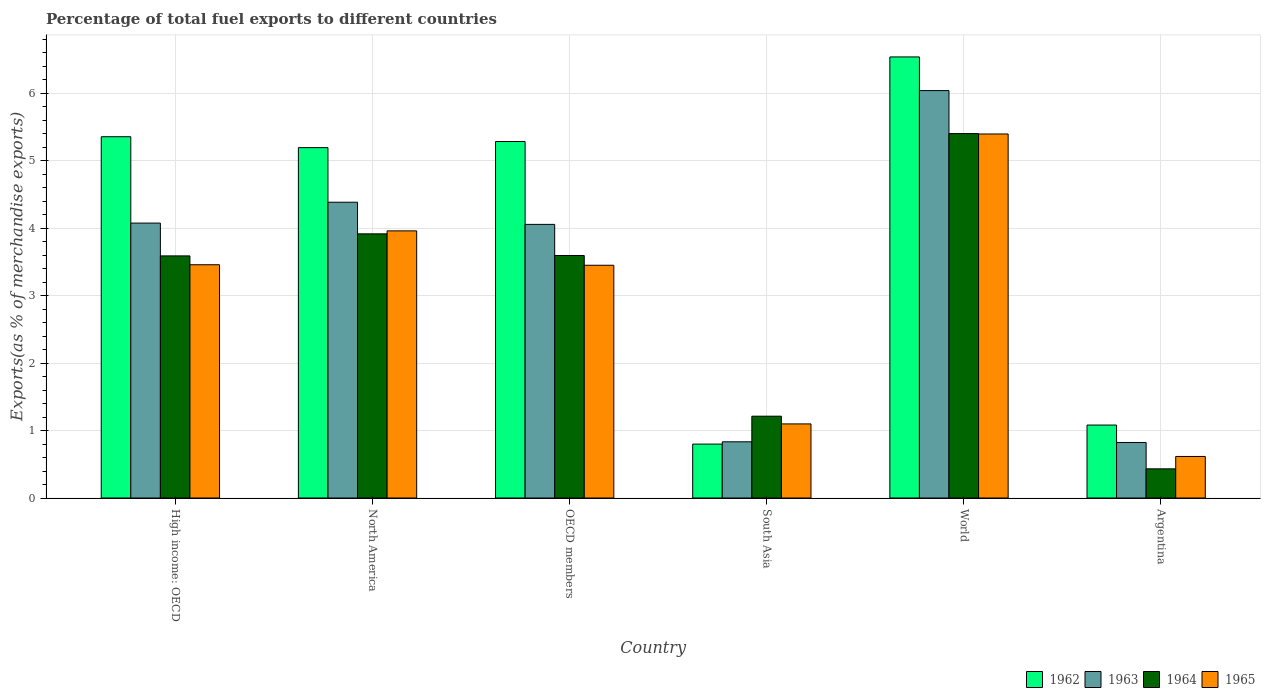How many different coloured bars are there?
Your response must be concise. 4. How many groups of bars are there?
Your answer should be very brief. 6. Are the number of bars per tick equal to the number of legend labels?
Give a very brief answer. Yes. How many bars are there on the 4th tick from the right?
Keep it short and to the point. 4. In how many cases, is the number of bars for a given country not equal to the number of legend labels?
Your response must be concise. 0. What is the percentage of exports to different countries in 1962 in High income: OECD?
Keep it short and to the point. 5.35. Across all countries, what is the maximum percentage of exports to different countries in 1965?
Your response must be concise. 5.39. Across all countries, what is the minimum percentage of exports to different countries in 1964?
Your answer should be very brief. 0.43. What is the total percentage of exports to different countries in 1962 in the graph?
Offer a terse response. 24.24. What is the difference between the percentage of exports to different countries in 1965 in North America and that in OECD members?
Ensure brevity in your answer.  0.51. What is the difference between the percentage of exports to different countries in 1963 in North America and the percentage of exports to different countries in 1964 in Argentina?
Keep it short and to the point. 3.95. What is the average percentage of exports to different countries in 1965 per country?
Provide a succinct answer. 2.99. What is the difference between the percentage of exports to different countries of/in 1965 and percentage of exports to different countries of/in 1964 in High income: OECD?
Provide a short and direct response. -0.13. In how many countries, is the percentage of exports to different countries in 1962 greater than 0.8 %?
Offer a very short reply. 5. What is the ratio of the percentage of exports to different countries in 1964 in North America to that in South Asia?
Give a very brief answer. 3.23. Is the difference between the percentage of exports to different countries in 1965 in OECD members and World greater than the difference between the percentage of exports to different countries in 1964 in OECD members and World?
Offer a terse response. No. What is the difference between the highest and the second highest percentage of exports to different countries in 1962?
Offer a terse response. -0.07. What is the difference between the highest and the lowest percentage of exports to different countries in 1963?
Provide a succinct answer. 5.21. Is the sum of the percentage of exports to different countries in 1963 in North America and OECD members greater than the maximum percentage of exports to different countries in 1964 across all countries?
Your response must be concise. Yes. Is it the case that in every country, the sum of the percentage of exports to different countries in 1963 and percentage of exports to different countries in 1962 is greater than the sum of percentage of exports to different countries in 1964 and percentage of exports to different countries in 1965?
Keep it short and to the point. No. What does the 3rd bar from the left in North America represents?
Provide a succinct answer. 1964. What does the 1st bar from the right in Argentina represents?
Make the answer very short. 1965. How many bars are there?
Your answer should be compact. 24. Are all the bars in the graph horizontal?
Offer a very short reply. No. What is the difference between two consecutive major ticks on the Y-axis?
Ensure brevity in your answer.  1. Does the graph contain any zero values?
Your response must be concise. No. Does the graph contain grids?
Your answer should be very brief. Yes. Where does the legend appear in the graph?
Your answer should be compact. Bottom right. How many legend labels are there?
Make the answer very short. 4. How are the legend labels stacked?
Ensure brevity in your answer.  Horizontal. What is the title of the graph?
Provide a succinct answer. Percentage of total fuel exports to different countries. Does "2011" appear as one of the legend labels in the graph?
Provide a short and direct response. No. What is the label or title of the X-axis?
Provide a succinct answer. Country. What is the label or title of the Y-axis?
Provide a succinct answer. Exports(as % of merchandise exports). What is the Exports(as % of merchandise exports) of 1962 in High income: OECD?
Your answer should be very brief. 5.35. What is the Exports(as % of merchandise exports) in 1963 in High income: OECD?
Offer a very short reply. 4.07. What is the Exports(as % of merchandise exports) of 1964 in High income: OECD?
Your answer should be compact. 3.59. What is the Exports(as % of merchandise exports) in 1965 in High income: OECD?
Provide a short and direct response. 3.46. What is the Exports(as % of merchandise exports) of 1962 in North America?
Make the answer very short. 5.19. What is the Exports(as % of merchandise exports) of 1963 in North America?
Offer a very short reply. 4.38. What is the Exports(as % of merchandise exports) of 1964 in North America?
Provide a succinct answer. 3.91. What is the Exports(as % of merchandise exports) of 1965 in North America?
Your response must be concise. 3.96. What is the Exports(as % of merchandise exports) in 1962 in OECD members?
Offer a terse response. 5.28. What is the Exports(as % of merchandise exports) in 1963 in OECD members?
Your answer should be compact. 4.05. What is the Exports(as % of merchandise exports) of 1964 in OECD members?
Offer a very short reply. 3.59. What is the Exports(as % of merchandise exports) in 1965 in OECD members?
Provide a succinct answer. 3.45. What is the Exports(as % of merchandise exports) of 1962 in South Asia?
Provide a succinct answer. 0.8. What is the Exports(as % of merchandise exports) in 1963 in South Asia?
Your answer should be compact. 0.83. What is the Exports(as % of merchandise exports) of 1964 in South Asia?
Provide a succinct answer. 1.21. What is the Exports(as % of merchandise exports) in 1965 in South Asia?
Make the answer very short. 1.1. What is the Exports(as % of merchandise exports) of 1962 in World?
Ensure brevity in your answer.  6.53. What is the Exports(as % of merchandise exports) of 1963 in World?
Provide a short and direct response. 6.04. What is the Exports(as % of merchandise exports) of 1964 in World?
Your answer should be very brief. 5.4. What is the Exports(as % of merchandise exports) of 1965 in World?
Provide a succinct answer. 5.39. What is the Exports(as % of merchandise exports) of 1962 in Argentina?
Your response must be concise. 1.08. What is the Exports(as % of merchandise exports) of 1963 in Argentina?
Your answer should be compact. 0.82. What is the Exports(as % of merchandise exports) of 1964 in Argentina?
Give a very brief answer. 0.43. What is the Exports(as % of merchandise exports) in 1965 in Argentina?
Offer a very short reply. 0.62. Across all countries, what is the maximum Exports(as % of merchandise exports) of 1962?
Ensure brevity in your answer.  6.53. Across all countries, what is the maximum Exports(as % of merchandise exports) in 1963?
Provide a succinct answer. 6.04. Across all countries, what is the maximum Exports(as % of merchandise exports) of 1964?
Ensure brevity in your answer.  5.4. Across all countries, what is the maximum Exports(as % of merchandise exports) in 1965?
Make the answer very short. 5.39. Across all countries, what is the minimum Exports(as % of merchandise exports) in 1962?
Your answer should be very brief. 0.8. Across all countries, what is the minimum Exports(as % of merchandise exports) of 1963?
Make the answer very short. 0.82. Across all countries, what is the minimum Exports(as % of merchandise exports) in 1964?
Your answer should be compact. 0.43. Across all countries, what is the minimum Exports(as % of merchandise exports) in 1965?
Your response must be concise. 0.62. What is the total Exports(as % of merchandise exports) of 1962 in the graph?
Give a very brief answer. 24.24. What is the total Exports(as % of merchandise exports) in 1963 in the graph?
Your answer should be very brief. 20.2. What is the total Exports(as % of merchandise exports) of 1964 in the graph?
Offer a very short reply. 18.14. What is the total Exports(as % of merchandise exports) in 1965 in the graph?
Ensure brevity in your answer.  17.97. What is the difference between the Exports(as % of merchandise exports) in 1962 in High income: OECD and that in North America?
Keep it short and to the point. 0.16. What is the difference between the Exports(as % of merchandise exports) of 1963 in High income: OECD and that in North America?
Give a very brief answer. -0.31. What is the difference between the Exports(as % of merchandise exports) of 1964 in High income: OECD and that in North America?
Offer a terse response. -0.33. What is the difference between the Exports(as % of merchandise exports) in 1965 in High income: OECD and that in North America?
Ensure brevity in your answer.  -0.5. What is the difference between the Exports(as % of merchandise exports) in 1962 in High income: OECD and that in OECD members?
Make the answer very short. 0.07. What is the difference between the Exports(as % of merchandise exports) in 1963 in High income: OECD and that in OECD members?
Ensure brevity in your answer.  0.02. What is the difference between the Exports(as % of merchandise exports) in 1964 in High income: OECD and that in OECD members?
Keep it short and to the point. -0.01. What is the difference between the Exports(as % of merchandise exports) in 1965 in High income: OECD and that in OECD members?
Provide a short and direct response. 0.01. What is the difference between the Exports(as % of merchandise exports) in 1962 in High income: OECD and that in South Asia?
Offer a terse response. 4.55. What is the difference between the Exports(as % of merchandise exports) of 1963 in High income: OECD and that in South Asia?
Keep it short and to the point. 3.24. What is the difference between the Exports(as % of merchandise exports) of 1964 in High income: OECD and that in South Asia?
Provide a succinct answer. 2.37. What is the difference between the Exports(as % of merchandise exports) of 1965 in High income: OECD and that in South Asia?
Your answer should be very brief. 2.36. What is the difference between the Exports(as % of merchandise exports) in 1962 in High income: OECD and that in World?
Give a very brief answer. -1.18. What is the difference between the Exports(as % of merchandise exports) of 1963 in High income: OECD and that in World?
Provide a succinct answer. -1.96. What is the difference between the Exports(as % of merchandise exports) of 1964 in High income: OECD and that in World?
Provide a short and direct response. -1.81. What is the difference between the Exports(as % of merchandise exports) in 1965 in High income: OECD and that in World?
Provide a succinct answer. -1.94. What is the difference between the Exports(as % of merchandise exports) of 1962 in High income: OECD and that in Argentina?
Your response must be concise. 4.27. What is the difference between the Exports(as % of merchandise exports) in 1963 in High income: OECD and that in Argentina?
Keep it short and to the point. 3.25. What is the difference between the Exports(as % of merchandise exports) in 1964 in High income: OECD and that in Argentina?
Provide a short and direct response. 3.15. What is the difference between the Exports(as % of merchandise exports) in 1965 in High income: OECD and that in Argentina?
Keep it short and to the point. 2.84. What is the difference between the Exports(as % of merchandise exports) of 1962 in North America and that in OECD members?
Your response must be concise. -0.09. What is the difference between the Exports(as % of merchandise exports) in 1963 in North America and that in OECD members?
Keep it short and to the point. 0.33. What is the difference between the Exports(as % of merchandise exports) of 1964 in North America and that in OECD members?
Offer a very short reply. 0.32. What is the difference between the Exports(as % of merchandise exports) of 1965 in North America and that in OECD members?
Keep it short and to the point. 0.51. What is the difference between the Exports(as % of merchandise exports) of 1962 in North America and that in South Asia?
Ensure brevity in your answer.  4.39. What is the difference between the Exports(as % of merchandise exports) in 1963 in North America and that in South Asia?
Make the answer very short. 3.55. What is the difference between the Exports(as % of merchandise exports) in 1964 in North America and that in South Asia?
Your answer should be compact. 2.7. What is the difference between the Exports(as % of merchandise exports) of 1965 in North America and that in South Asia?
Ensure brevity in your answer.  2.86. What is the difference between the Exports(as % of merchandise exports) in 1962 in North America and that in World?
Your answer should be very brief. -1.34. What is the difference between the Exports(as % of merchandise exports) of 1963 in North America and that in World?
Your answer should be very brief. -1.65. What is the difference between the Exports(as % of merchandise exports) of 1964 in North America and that in World?
Offer a terse response. -1.49. What is the difference between the Exports(as % of merchandise exports) of 1965 in North America and that in World?
Your answer should be compact. -1.44. What is the difference between the Exports(as % of merchandise exports) of 1962 in North America and that in Argentina?
Your answer should be compact. 4.11. What is the difference between the Exports(as % of merchandise exports) in 1963 in North America and that in Argentina?
Your response must be concise. 3.56. What is the difference between the Exports(as % of merchandise exports) of 1964 in North America and that in Argentina?
Provide a succinct answer. 3.48. What is the difference between the Exports(as % of merchandise exports) in 1965 in North America and that in Argentina?
Provide a short and direct response. 3.34. What is the difference between the Exports(as % of merchandise exports) of 1962 in OECD members and that in South Asia?
Provide a short and direct response. 4.48. What is the difference between the Exports(as % of merchandise exports) of 1963 in OECD members and that in South Asia?
Ensure brevity in your answer.  3.22. What is the difference between the Exports(as % of merchandise exports) of 1964 in OECD members and that in South Asia?
Provide a succinct answer. 2.38. What is the difference between the Exports(as % of merchandise exports) in 1965 in OECD members and that in South Asia?
Give a very brief answer. 2.35. What is the difference between the Exports(as % of merchandise exports) in 1962 in OECD members and that in World?
Offer a very short reply. -1.25. What is the difference between the Exports(as % of merchandise exports) in 1963 in OECD members and that in World?
Your answer should be very brief. -1.98. What is the difference between the Exports(as % of merchandise exports) in 1964 in OECD members and that in World?
Give a very brief answer. -1.81. What is the difference between the Exports(as % of merchandise exports) of 1965 in OECD members and that in World?
Provide a short and direct response. -1.94. What is the difference between the Exports(as % of merchandise exports) in 1962 in OECD members and that in Argentina?
Provide a succinct answer. 4.2. What is the difference between the Exports(as % of merchandise exports) of 1963 in OECD members and that in Argentina?
Keep it short and to the point. 3.23. What is the difference between the Exports(as % of merchandise exports) of 1964 in OECD members and that in Argentina?
Keep it short and to the point. 3.16. What is the difference between the Exports(as % of merchandise exports) in 1965 in OECD members and that in Argentina?
Ensure brevity in your answer.  2.83. What is the difference between the Exports(as % of merchandise exports) of 1962 in South Asia and that in World?
Your answer should be very brief. -5.74. What is the difference between the Exports(as % of merchandise exports) of 1963 in South Asia and that in World?
Ensure brevity in your answer.  -5.2. What is the difference between the Exports(as % of merchandise exports) in 1964 in South Asia and that in World?
Give a very brief answer. -4.19. What is the difference between the Exports(as % of merchandise exports) of 1965 in South Asia and that in World?
Keep it short and to the point. -4.3. What is the difference between the Exports(as % of merchandise exports) of 1962 in South Asia and that in Argentina?
Your answer should be very brief. -0.28. What is the difference between the Exports(as % of merchandise exports) in 1963 in South Asia and that in Argentina?
Make the answer very short. 0.01. What is the difference between the Exports(as % of merchandise exports) of 1964 in South Asia and that in Argentina?
Provide a short and direct response. 0.78. What is the difference between the Exports(as % of merchandise exports) of 1965 in South Asia and that in Argentina?
Ensure brevity in your answer.  0.48. What is the difference between the Exports(as % of merchandise exports) of 1962 in World and that in Argentina?
Make the answer very short. 5.45. What is the difference between the Exports(as % of merchandise exports) in 1963 in World and that in Argentina?
Offer a terse response. 5.21. What is the difference between the Exports(as % of merchandise exports) in 1964 in World and that in Argentina?
Ensure brevity in your answer.  4.97. What is the difference between the Exports(as % of merchandise exports) in 1965 in World and that in Argentina?
Your answer should be very brief. 4.78. What is the difference between the Exports(as % of merchandise exports) of 1962 in High income: OECD and the Exports(as % of merchandise exports) of 1963 in North America?
Your answer should be compact. 0.97. What is the difference between the Exports(as % of merchandise exports) of 1962 in High income: OECD and the Exports(as % of merchandise exports) of 1964 in North America?
Your answer should be very brief. 1.44. What is the difference between the Exports(as % of merchandise exports) of 1962 in High income: OECD and the Exports(as % of merchandise exports) of 1965 in North America?
Provide a succinct answer. 1.39. What is the difference between the Exports(as % of merchandise exports) of 1963 in High income: OECD and the Exports(as % of merchandise exports) of 1964 in North America?
Make the answer very short. 0.16. What is the difference between the Exports(as % of merchandise exports) in 1963 in High income: OECD and the Exports(as % of merchandise exports) in 1965 in North America?
Give a very brief answer. 0.12. What is the difference between the Exports(as % of merchandise exports) of 1964 in High income: OECD and the Exports(as % of merchandise exports) of 1965 in North America?
Your answer should be very brief. -0.37. What is the difference between the Exports(as % of merchandise exports) of 1962 in High income: OECD and the Exports(as % of merchandise exports) of 1963 in OECD members?
Your answer should be very brief. 1.3. What is the difference between the Exports(as % of merchandise exports) of 1962 in High income: OECD and the Exports(as % of merchandise exports) of 1964 in OECD members?
Make the answer very short. 1.76. What is the difference between the Exports(as % of merchandise exports) of 1962 in High income: OECD and the Exports(as % of merchandise exports) of 1965 in OECD members?
Keep it short and to the point. 1.9. What is the difference between the Exports(as % of merchandise exports) of 1963 in High income: OECD and the Exports(as % of merchandise exports) of 1964 in OECD members?
Provide a short and direct response. 0.48. What is the difference between the Exports(as % of merchandise exports) in 1963 in High income: OECD and the Exports(as % of merchandise exports) in 1965 in OECD members?
Ensure brevity in your answer.  0.62. What is the difference between the Exports(as % of merchandise exports) of 1964 in High income: OECD and the Exports(as % of merchandise exports) of 1965 in OECD members?
Offer a very short reply. 0.14. What is the difference between the Exports(as % of merchandise exports) in 1962 in High income: OECD and the Exports(as % of merchandise exports) in 1963 in South Asia?
Offer a very short reply. 4.52. What is the difference between the Exports(as % of merchandise exports) in 1962 in High income: OECD and the Exports(as % of merchandise exports) in 1964 in South Asia?
Offer a very short reply. 4.14. What is the difference between the Exports(as % of merchandise exports) in 1962 in High income: OECD and the Exports(as % of merchandise exports) in 1965 in South Asia?
Your response must be concise. 4.25. What is the difference between the Exports(as % of merchandise exports) in 1963 in High income: OECD and the Exports(as % of merchandise exports) in 1964 in South Asia?
Provide a short and direct response. 2.86. What is the difference between the Exports(as % of merchandise exports) in 1963 in High income: OECD and the Exports(as % of merchandise exports) in 1965 in South Asia?
Provide a short and direct response. 2.98. What is the difference between the Exports(as % of merchandise exports) of 1964 in High income: OECD and the Exports(as % of merchandise exports) of 1965 in South Asia?
Give a very brief answer. 2.49. What is the difference between the Exports(as % of merchandise exports) in 1962 in High income: OECD and the Exports(as % of merchandise exports) in 1963 in World?
Give a very brief answer. -0.68. What is the difference between the Exports(as % of merchandise exports) of 1962 in High income: OECD and the Exports(as % of merchandise exports) of 1964 in World?
Your answer should be very brief. -0.05. What is the difference between the Exports(as % of merchandise exports) of 1962 in High income: OECD and the Exports(as % of merchandise exports) of 1965 in World?
Your answer should be very brief. -0.04. What is the difference between the Exports(as % of merchandise exports) of 1963 in High income: OECD and the Exports(as % of merchandise exports) of 1964 in World?
Make the answer very short. -1.33. What is the difference between the Exports(as % of merchandise exports) of 1963 in High income: OECD and the Exports(as % of merchandise exports) of 1965 in World?
Your response must be concise. -1.32. What is the difference between the Exports(as % of merchandise exports) of 1964 in High income: OECD and the Exports(as % of merchandise exports) of 1965 in World?
Your answer should be very brief. -1.81. What is the difference between the Exports(as % of merchandise exports) in 1962 in High income: OECD and the Exports(as % of merchandise exports) in 1963 in Argentina?
Keep it short and to the point. 4.53. What is the difference between the Exports(as % of merchandise exports) of 1962 in High income: OECD and the Exports(as % of merchandise exports) of 1964 in Argentina?
Your response must be concise. 4.92. What is the difference between the Exports(as % of merchandise exports) of 1962 in High income: OECD and the Exports(as % of merchandise exports) of 1965 in Argentina?
Your answer should be very brief. 4.74. What is the difference between the Exports(as % of merchandise exports) of 1963 in High income: OECD and the Exports(as % of merchandise exports) of 1964 in Argentina?
Provide a short and direct response. 3.64. What is the difference between the Exports(as % of merchandise exports) in 1963 in High income: OECD and the Exports(as % of merchandise exports) in 1965 in Argentina?
Your response must be concise. 3.46. What is the difference between the Exports(as % of merchandise exports) in 1964 in High income: OECD and the Exports(as % of merchandise exports) in 1965 in Argentina?
Keep it short and to the point. 2.97. What is the difference between the Exports(as % of merchandise exports) in 1962 in North America and the Exports(as % of merchandise exports) in 1963 in OECD members?
Your answer should be very brief. 1.14. What is the difference between the Exports(as % of merchandise exports) of 1962 in North America and the Exports(as % of merchandise exports) of 1964 in OECD members?
Ensure brevity in your answer.  1.6. What is the difference between the Exports(as % of merchandise exports) in 1962 in North America and the Exports(as % of merchandise exports) in 1965 in OECD members?
Keep it short and to the point. 1.74. What is the difference between the Exports(as % of merchandise exports) of 1963 in North America and the Exports(as % of merchandise exports) of 1964 in OECD members?
Make the answer very short. 0.79. What is the difference between the Exports(as % of merchandise exports) of 1963 in North America and the Exports(as % of merchandise exports) of 1965 in OECD members?
Your response must be concise. 0.93. What is the difference between the Exports(as % of merchandise exports) of 1964 in North America and the Exports(as % of merchandise exports) of 1965 in OECD members?
Offer a very short reply. 0.47. What is the difference between the Exports(as % of merchandise exports) in 1962 in North America and the Exports(as % of merchandise exports) in 1963 in South Asia?
Provide a short and direct response. 4.36. What is the difference between the Exports(as % of merchandise exports) in 1962 in North America and the Exports(as % of merchandise exports) in 1964 in South Asia?
Make the answer very short. 3.98. What is the difference between the Exports(as % of merchandise exports) in 1962 in North America and the Exports(as % of merchandise exports) in 1965 in South Asia?
Offer a very short reply. 4.09. What is the difference between the Exports(as % of merchandise exports) in 1963 in North America and the Exports(as % of merchandise exports) in 1964 in South Asia?
Your response must be concise. 3.17. What is the difference between the Exports(as % of merchandise exports) of 1963 in North America and the Exports(as % of merchandise exports) of 1965 in South Asia?
Your answer should be compact. 3.28. What is the difference between the Exports(as % of merchandise exports) in 1964 in North America and the Exports(as % of merchandise exports) in 1965 in South Asia?
Offer a very short reply. 2.82. What is the difference between the Exports(as % of merchandise exports) of 1962 in North America and the Exports(as % of merchandise exports) of 1963 in World?
Ensure brevity in your answer.  -0.85. What is the difference between the Exports(as % of merchandise exports) in 1962 in North America and the Exports(as % of merchandise exports) in 1964 in World?
Provide a short and direct response. -0.21. What is the difference between the Exports(as % of merchandise exports) of 1962 in North America and the Exports(as % of merchandise exports) of 1965 in World?
Your answer should be compact. -0.2. What is the difference between the Exports(as % of merchandise exports) in 1963 in North America and the Exports(as % of merchandise exports) in 1964 in World?
Keep it short and to the point. -1.02. What is the difference between the Exports(as % of merchandise exports) in 1963 in North America and the Exports(as % of merchandise exports) in 1965 in World?
Keep it short and to the point. -1.01. What is the difference between the Exports(as % of merchandise exports) in 1964 in North America and the Exports(as % of merchandise exports) in 1965 in World?
Provide a succinct answer. -1.48. What is the difference between the Exports(as % of merchandise exports) of 1962 in North America and the Exports(as % of merchandise exports) of 1963 in Argentina?
Ensure brevity in your answer.  4.37. What is the difference between the Exports(as % of merchandise exports) of 1962 in North America and the Exports(as % of merchandise exports) of 1964 in Argentina?
Your response must be concise. 4.76. What is the difference between the Exports(as % of merchandise exports) in 1962 in North America and the Exports(as % of merchandise exports) in 1965 in Argentina?
Your answer should be very brief. 4.58. What is the difference between the Exports(as % of merchandise exports) of 1963 in North America and the Exports(as % of merchandise exports) of 1964 in Argentina?
Offer a very short reply. 3.95. What is the difference between the Exports(as % of merchandise exports) of 1963 in North America and the Exports(as % of merchandise exports) of 1965 in Argentina?
Your response must be concise. 3.77. What is the difference between the Exports(as % of merchandise exports) in 1964 in North America and the Exports(as % of merchandise exports) in 1965 in Argentina?
Ensure brevity in your answer.  3.3. What is the difference between the Exports(as % of merchandise exports) of 1962 in OECD members and the Exports(as % of merchandise exports) of 1963 in South Asia?
Offer a very short reply. 4.45. What is the difference between the Exports(as % of merchandise exports) in 1962 in OECD members and the Exports(as % of merchandise exports) in 1964 in South Asia?
Offer a terse response. 4.07. What is the difference between the Exports(as % of merchandise exports) of 1962 in OECD members and the Exports(as % of merchandise exports) of 1965 in South Asia?
Your answer should be compact. 4.18. What is the difference between the Exports(as % of merchandise exports) in 1963 in OECD members and the Exports(as % of merchandise exports) in 1964 in South Asia?
Your answer should be compact. 2.84. What is the difference between the Exports(as % of merchandise exports) of 1963 in OECD members and the Exports(as % of merchandise exports) of 1965 in South Asia?
Ensure brevity in your answer.  2.96. What is the difference between the Exports(as % of merchandise exports) of 1964 in OECD members and the Exports(as % of merchandise exports) of 1965 in South Asia?
Provide a succinct answer. 2.5. What is the difference between the Exports(as % of merchandise exports) of 1962 in OECD members and the Exports(as % of merchandise exports) of 1963 in World?
Offer a very short reply. -0.75. What is the difference between the Exports(as % of merchandise exports) of 1962 in OECD members and the Exports(as % of merchandise exports) of 1964 in World?
Your response must be concise. -0.12. What is the difference between the Exports(as % of merchandise exports) of 1962 in OECD members and the Exports(as % of merchandise exports) of 1965 in World?
Your answer should be compact. -0.11. What is the difference between the Exports(as % of merchandise exports) in 1963 in OECD members and the Exports(as % of merchandise exports) in 1964 in World?
Your answer should be compact. -1.35. What is the difference between the Exports(as % of merchandise exports) in 1963 in OECD members and the Exports(as % of merchandise exports) in 1965 in World?
Provide a short and direct response. -1.34. What is the difference between the Exports(as % of merchandise exports) of 1964 in OECD members and the Exports(as % of merchandise exports) of 1965 in World?
Provide a short and direct response. -1.8. What is the difference between the Exports(as % of merchandise exports) in 1962 in OECD members and the Exports(as % of merchandise exports) in 1963 in Argentina?
Offer a very short reply. 4.46. What is the difference between the Exports(as % of merchandise exports) of 1962 in OECD members and the Exports(as % of merchandise exports) of 1964 in Argentina?
Provide a short and direct response. 4.85. What is the difference between the Exports(as % of merchandise exports) of 1962 in OECD members and the Exports(as % of merchandise exports) of 1965 in Argentina?
Your answer should be very brief. 4.67. What is the difference between the Exports(as % of merchandise exports) of 1963 in OECD members and the Exports(as % of merchandise exports) of 1964 in Argentina?
Your answer should be very brief. 3.62. What is the difference between the Exports(as % of merchandise exports) in 1963 in OECD members and the Exports(as % of merchandise exports) in 1965 in Argentina?
Your answer should be compact. 3.44. What is the difference between the Exports(as % of merchandise exports) of 1964 in OECD members and the Exports(as % of merchandise exports) of 1965 in Argentina?
Your response must be concise. 2.98. What is the difference between the Exports(as % of merchandise exports) of 1962 in South Asia and the Exports(as % of merchandise exports) of 1963 in World?
Provide a succinct answer. -5.24. What is the difference between the Exports(as % of merchandise exports) in 1962 in South Asia and the Exports(as % of merchandise exports) in 1964 in World?
Your answer should be very brief. -4.6. What is the difference between the Exports(as % of merchandise exports) in 1962 in South Asia and the Exports(as % of merchandise exports) in 1965 in World?
Your response must be concise. -4.59. What is the difference between the Exports(as % of merchandise exports) of 1963 in South Asia and the Exports(as % of merchandise exports) of 1964 in World?
Offer a terse response. -4.57. What is the difference between the Exports(as % of merchandise exports) of 1963 in South Asia and the Exports(as % of merchandise exports) of 1965 in World?
Keep it short and to the point. -4.56. What is the difference between the Exports(as % of merchandise exports) of 1964 in South Asia and the Exports(as % of merchandise exports) of 1965 in World?
Keep it short and to the point. -4.18. What is the difference between the Exports(as % of merchandise exports) in 1962 in South Asia and the Exports(as % of merchandise exports) in 1963 in Argentina?
Provide a short and direct response. -0.02. What is the difference between the Exports(as % of merchandise exports) of 1962 in South Asia and the Exports(as % of merchandise exports) of 1964 in Argentina?
Your response must be concise. 0.37. What is the difference between the Exports(as % of merchandise exports) in 1962 in South Asia and the Exports(as % of merchandise exports) in 1965 in Argentina?
Your answer should be very brief. 0.18. What is the difference between the Exports(as % of merchandise exports) of 1963 in South Asia and the Exports(as % of merchandise exports) of 1964 in Argentina?
Your answer should be compact. 0.4. What is the difference between the Exports(as % of merchandise exports) in 1963 in South Asia and the Exports(as % of merchandise exports) in 1965 in Argentina?
Your answer should be compact. 0.22. What is the difference between the Exports(as % of merchandise exports) in 1964 in South Asia and the Exports(as % of merchandise exports) in 1965 in Argentina?
Ensure brevity in your answer.  0.6. What is the difference between the Exports(as % of merchandise exports) of 1962 in World and the Exports(as % of merchandise exports) of 1963 in Argentina?
Your answer should be compact. 5.71. What is the difference between the Exports(as % of merchandise exports) of 1962 in World and the Exports(as % of merchandise exports) of 1964 in Argentina?
Your answer should be compact. 6.1. What is the difference between the Exports(as % of merchandise exports) in 1962 in World and the Exports(as % of merchandise exports) in 1965 in Argentina?
Ensure brevity in your answer.  5.92. What is the difference between the Exports(as % of merchandise exports) of 1963 in World and the Exports(as % of merchandise exports) of 1964 in Argentina?
Provide a succinct answer. 5.6. What is the difference between the Exports(as % of merchandise exports) of 1963 in World and the Exports(as % of merchandise exports) of 1965 in Argentina?
Your answer should be very brief. 5.42. What is the difference between the Exports(as % of merchandise exports) in 1964 in World and the Exports(as % of merchandise exports) in 1965 in Argentina?
Ensure brevity in your answer.  4.78. What is the average Exports(as % of merchandise exports) in 1962 per country?
Give a very brief answer. 4.04. What is the average Exports(as % of merchandise exports) of 1963 per country?
Give a very brief answer. 3.37. What is the average Exports(as % of merchandise exports) of 1964 per country?
Offer a terse response. 3.02. What is the average Exports(as % of merchandise exports) of 1965 per country?
Make the answer very short. 2.99. What is the difference between the Exports(as % of merchandise exports) of 1962 and Exports(as % of merchandise exports) of 1963 in High income: OECD?
Offer a terse response. 1.28. What is the difference between the Exports(as % of merchandise exports) of 1962 and Exports(as % of merchandise exports) of 1964 in High income: OECD?
Provide a succinct answer. 1.77. What is the difference between the Exports(as % of merchandise exports) in 1962 and Exports(as % of merchandise exports) in 1965 in High income: OECD?
Keep it short and to the point. 1.9. What is the difference between the Exports(as % of merchandise exports) in 1963 and Exports(as % of merchandise exports) in 1964 in High income: OECD?
Make the answer very short. 0.49. What is the difference between the Exports(as % of merchandise exports) of 1963 and Exports(as % of merchandise exports) of 1965 in High income: OECD?
Provide a succinct answer. 0.62. What is the difference between the Exports(as % of merchandise exports) of 1964 and Exports(as % of merchandise exports) of 1965 in High income: OECD?
Provide a succinct answer. 0.13. What is the difference between the Exports(as % of merchandise exports) in 1962 and Exports(as % of merchandise exports) in 1963 in North America?
Provide a succinct answer. 0.81. What is the difference between the Exports(as % of merchandise exports) of 1962 and Exports(as % of merchandise exports) of 1964 in North America?
Give a very brief answer. 1.28. What is the difference between the Exports(as % of merchandise exports) of 1962 and Exports(as % of merchandise exports) of 1965 in North America?
Your answer should be compact. 1.23. What is the difference between the Exports(as % of merchandise exports) in 1963 and Exports(as % of merchandise exports) in 1964 in North America?
Offer a very short reply. 0.47. What is the difference between the Exports(as % of merchandise exports) of 1963 and Exports(as % of merchandise exports) of 1965 in North America?
Provide a short and direct response. 0.42. What is the difference between the Exports(as % of merchandise exports) of 1964 and Exports(as % of merchandise exports) of 1965 in North America?
Your response must be concise. -0.04. What is the difference between the Exports(as % of merchandise exports) in 1962 and Exports(as % of merchandise exports) in 1963 in OECD members?
Your answer should be very brief. 1.23. What is the difference between the Exports(as % of merchandise exports) in 1962 and Exports(as % of merchandise exports) in 1964 in OECD members?
Provide a short and direct response. 1.69. What is the difference between the Exports(as % of merchandise exports) in 1962 and Exports(as % of merchandise exports) in 1965 in OECD members?
Make the answer very short. 1.83. What is the difference between the Exports(as % of merchandise exports) of 1963 and Exports(as % of merchandise exports) of 1964 in OECD members?
Provide a short and direct response. 0.46. What is the difference between the Exports(as % of merchandise exports) of 1963 and Exports(as % of merchandise exports) of 1965 in OECD members?
Provide a succinct answer. 0.61. What is the difference between the Exports(as % of merchandise exports) in 1964 and Exports(as % of merchandise exports) in 1965 in OECD members?
Offer a very short reply. 0.14. What is the difference between the Exports(as % of merchandise exports) of 1962 and Exports(as % of merchandise exports) of 1963 in South Asia?
Provide a short and direct response. -0.03. What is the difference between the Exports(as % of merchandise exports) in 1962 and Exports(as % of merchandise exports) in 1964 in South Asia?
Make the answer very short. -0.41. What is the difference between the Exports(as % of merchandise exports) of 1962 and Exports(as % of merchandise exports) of 1965 in South Asia?
Ensure brevity in your answer.  -0.3. What is the difference between the Exports(as % of merchandise exports) in 1963 and Exports(as % of merchandise exports) in 1964 in South Asia?
Your answer should be compact. -0.38. What is the difference between the Exports(as % of merchandise exports) in 1963 and Exports(as % of merchandise exports) in 1965 in South Asia?
Keep it short and to the point. -0.27. What is the difference between the Exports(as % of merchandise exports) of 1964 and Exports(as % of merchandise exports) of 1965 in South Asia?
Your response must be concise. 0.11. What is the difference between the Exports(as % of merchandise exports) of 1962 and Exports(as % of merchandise exports) of 1963 in World?
Offer a very short reply. 0.5. What is the difference between the Exports(as % of merchandise exports) of 1962 and Exports(as % of merchandise exports) of 1964 in World?
Your response must be concise. 1.14. What is the difference between the Exports(as % of merchandise exports) in 1962 and Exports(as % of merchandise exports) in 1965 in World?
Give a very brief answer. 1.14. What is the difference between the Exports(as % of merchandise exports) in 1963 and Exports(as % of merchandise exports) in 1964 in World?
Ensure brevity in your answer.  0.64. What is the difference between the Exports(as % of merchandise exports) in 1963 and Exports(as % of merchandise exports) in 1965 in World?
Your answer should be very brief. 0.64. What is the difference between the Exports(as % of merchandise exports) in 1964 and Exports(as % of merchandise exports) in 1965 in World?
Provide a succinct answer. 0.01. What is the difference between the Exports(as % of merchandise exports) of 1962 and Exports(as % of merchandise exports) of 1963 in Argentina?
Provide a succinct answer. 0.26. What is the difference between the Exports(as % of merchandise exports) of 1962 and Exports(as % of merchandise exports) of 1964 in Argentina?
Your response must be concise. 0.65. What is the difference between the Exports(as % of merchandise exports) in 1962 and Exports(as % of merchandise exports) in 1965 in Argentina?
Offer a very short reply. 0.47. What is the difference between the Exports(as % of merchandise exports) in 1963 and Exports(as % of merchandise exports) in 1964 in Argentina?
Ensure brevity in your answer.  0.39. What is the difference between the Exports(as % of merchandise exports) in 1963 and Exports(as % of merchandise exports) in 1965 in Argentina?
Offer a terse response. 0.21. What is the difference between the Exports(as % of merchandise exports) in 1964 and Exports(as % of merchandise exports) in 1965 in Argentina?
Offer a terse response. -0.18. What is the ratio of the Exports(as % of merchandise exports) in 1962 in High income: OECD to that in North America?
Make the answer very short. 1.03. What is the ratio of the Exports(as % of merchandise exports) of 1963 in High income: OECD to that in North America?
Offer a terse response. 0.93. What is the ratio of the Exports(as % of merchandise exports) of 1964 in High income: OECD to that in North America?
Your response must be concise. 0.92. What is the ratio of the Exports(as % of merchandise exports) of 1965 in High income: OECD to that in North America?
Offer a very short reply. 0.87. What is the ratio of the Exports(as % of merchandise exports) of 1962 in High income: OECD to that in OECD members?
Offer a very short reply. 1.01. What is the ratio of the Exports(as % of merchandise exports) in 1963 in High income: OECD to that in OECD members?
Offer a terse response. 1. What is the ratio of the Exports(as % of merchandise exports) in 1964 in High income: OECD to that in OECD members?
Offer a very short reply. 1. What is the ratio of the Exports(as % of merchandise exports) in 1962 in High income: OECD to that in South Asia?
Ensure brevity in your answer.  6.7. What is the ratio of the Exports(as % of merchandise exports) in 1963 in High income: OECD to that in South Asia?
Your response must be concise. 4.89. What is the ratio of the Exports(as % of merchandise exports) of 1964 in High income: OECD to that in South Asia?
Give a very brief answer. 2.96. What is the ratio of the Exports(as % of merchandise exports) in 1965 in High income: OECD to that in South Asia?
Your answer should be compact. 3.15. What is the ratio of the Exports(as % of merchandise exports) in 1962 in High income: OECD to that in World?
Keep it short and to the point. 0.82. What is the ratio of the Exports(as % of merchandise exports) in 1963 in High income: OECD to that in World?
Provide a short and direct response. 0.67. What is the ratio of the Exports(as % of merchandise exports) of 1964 in High income: OECD to that in World?
Give a very brief answer. 0.66. What is the ratio of the Exports(as % of merchandise exports) in 1965 in High income: OECD to that in World?
Provide a succinct answer. 0.64. What is the ratio of the Exports(as % of merchandise exports) in 1962 in High income: OECD to that in Argentina?
Offer a terse response. 4.95. What is the ratio of the Exports(as % of merchandise exports) in 1963 in High income: OECD to that in Argentina?
Ensure brevity in your answer.  4.95. What is the ratio of the Exports(as % of merchandise exports) of 1964 in High income: OECD to that in Argentina?
Keep it short and to the point. 8.3. What is the ratio of the Exports(as % of merchandise exports) in 1965 in High income: OECD to that in Argentina?
Your response must be concise. 5.61. What is the ratio of the Exports(as % of merchandise exports) of 1962 in North America to that in OECD members?
Provide a succinct answer. 0.98. What is the ratio of the Exports(as % of merchandise exports) in 1963 in North America to that in OECD members?
Make the answer very short. 1.08. What is the ratio of the Exports(as % of merchandise exports) of 1964 in North America to that in OECD members?
Offer a terse response. 1.09. What is the ratio of the Exports(as % of merchandise exports) of 1965 in North America to that in OECD members?
Ensure brevity in your answer.  1.15. What is the ratio of the Exports(as % of merchandise exports) of 1962 in North America to that in South Asia?
Make the answer very short. 6.5. What is the ratio of the Exports(as % of merchandise exports) in 1963 in North America to that in South Asia?
Your answer should be very brief. 5.26. What is the ratio of the Exports(as % of merchandise exports) of 1964 in North America to that in South Asia?
Give a very brief answer. 3.23. What is the ratio of the Exports(as % of merchandise exports) of 1965 in North America to that in South Asia?
Give a very brief answer. 3.61. What is the ratio of the Exports(as % of merchandise exports) in 1962 in North America to that in World?
Offer a terse response. 0.79. What is the ratio of the Exports(as % of merchandise exports) of 1963 in North America to that in World?
Your answer should be very brief. 0.73. What is the ratio of the Exports(as % of merchandise exports) in 1964 in North America to that in World?
Your response must be concise. 0.72. What is the ratio of the Exports(as % of merchandise exports) of 1965 in North America to that in World?
Keep it short and to the point. 0.73. What is the ratio of the Exports(as % of merchandise exports) in 1962 in North America to that in Argentina?
Provide a succinct answer. 4.8. What is the ratio of the Exports(as % of merchandise exports) of 1963 in North America to that in Argentina?
Your answer should be compact. 5.33. What is the ratio of the Exports(as % of merchandise exports) of 1964 in North America to that in Argentina?
Offer a very short reply. 9.05. What is the ratio of the Exports(as % of merchandise exports) of 1965 in North America to that in Argentina?
Your answer should be very brief. 6.43. What is the ratio of the Exports(as % of merchandise exports) in 1962 in OECD members to that in South Asia?
Give a very brief answer. 6.61. What is the ratio of the Exports(as % of merchandise exports) of 1963 in OECD members to that in South Asia?
Provide a succinct answer. 4.87. What is the ratio of the Exports(as % of merchandise exports) in 1964 in OECD members to that in South Asia?
Your answer should be very brief. 2.96. What is the ratio of the Exports(as % of merchandise exports) in 1965 in OECD members to that in South Asia?
Provide a succinct answer. 3.14. What is the ratio of the Exports(as % of merchandise exports) in 1962 in OECD members to that in World?
Your answer should be compact. 0.81. What is the ratio of the Exports(as % of merchandise exports) in 1963 in OECD members to that in World?
Your answer should be compact. 0.67. What is the ratio of the Exports(as % of merchandise exports) of 1964 in OECD members to that in World?
Offer a very short reply. 0.67. What is the ratio of the Exports(as % of merchandise exports) of 1965 in OECD members to that in World?
Your response must be concise. 0.64. What is the ratio of the Exports(as % of merchandise exports) in 1962 in OECD members to that in Argentina?
Offer a very short reply. 4.89. What is the ratio of the Exports(as % of merchandise exports) of 1963 in OECD members to that in Argentina?
Offer a terse response. 4.93. What is the ratio of the Exports(as % of merchandise exports) in 1964 in OECD members to that in Argentina?
Your response must be concise. 8.31. What is the ratio of the Exports(as % of merchandise exports) of 1965 in OECD members to that in Argentina?
Give a very brief answer. 5.6. What is the ratio of the Exports(as % of merchandise exports) in 1962 in South Asia to that in World?
Offer a terse response. 0.12. What is the ratio of the Exports(as % of merchandise exports) in 1963 in South Asia to that in World?
Your response must be concise. 0.14. What is the ratio of the Exports(as % of merchandise exports) in 1964 in South Asia to that in World?
Offer a terse response. 0.22. What is the ratio of the Exports(as % of merchandise exports) in 1965 in South Asia to that in World?
Make the answer very short. 0.2. What is the ratio of the Exports(as % of merchandise exports) of 1962 in South Asia to that in Argentina?
Your response must be concise. 0.74. What is the ratio of the Exports(as % of merchandise exports) in 1963 in South Asia to that in Argentina?
Your answer should be very brief. 1.01. What is the ratio of the Exports(as % of merchandise exports) in 1964 in South Asia to that in Argentina?
Offer a terse response. 2.8. What is the ratio of the Exports(as % of merchandise exports) in 1965 in South Asia to that in Argentina?
Provide a short and direct response. 1.78. What is the ratio of the Exports(as % of merchandise exports) of 1962 in World to that in Argentina?
Keep it short and to the point. 6.05. What is the ratio of the Exports(as % of merchandise exports) in 1963 in World to that in Argentina?
Ensure brevity in your answer.  7.34. What is the ratio of the Exports(as % of merchandise exports) in 1964 in World to that in Argentina?
Make the answer very short. 12.49. What is the ratio of the Exports(as % of merchandise exports) in 1965 in World to that in Argentina?
Keep it short and to the point. 8.76. What is the difference between the highest and the second highest Exports(as % of merchandise exports) in 1962?
Offer a very short reply. 1.18. What is the difference between the highest and the second highest Exports(as % of merchandise exports) of 1963?
Ensure brevity in your answer.  1.65. What is the difference between the highest and the second highest Exports(as % of merchandise exports) in 1964?
Your answer should be very brief. 1.49. What is the difference between the highest and the second highest Exports(as % of merchandise exports) of 1965?
Your answer should be compact. 1.44. What is the difference between the highest and the lowest Exports(as % of merchandise exports) in 1962?
Your answer should be compact. 5.74. What is the difference between the highest and the lowest Exports(as % of merchandise exports) in 1963?
Offer a terse response. 5.21. What is the difference between the highest and the lowest Exports(as % of merchandise exports) of 1964?
Ensure brevity in your answer.  4.97. What is the difference between the highest and the lowest Exports(as % of merchandise exports) in 1965?
Offer a very short reply. 4.78. 